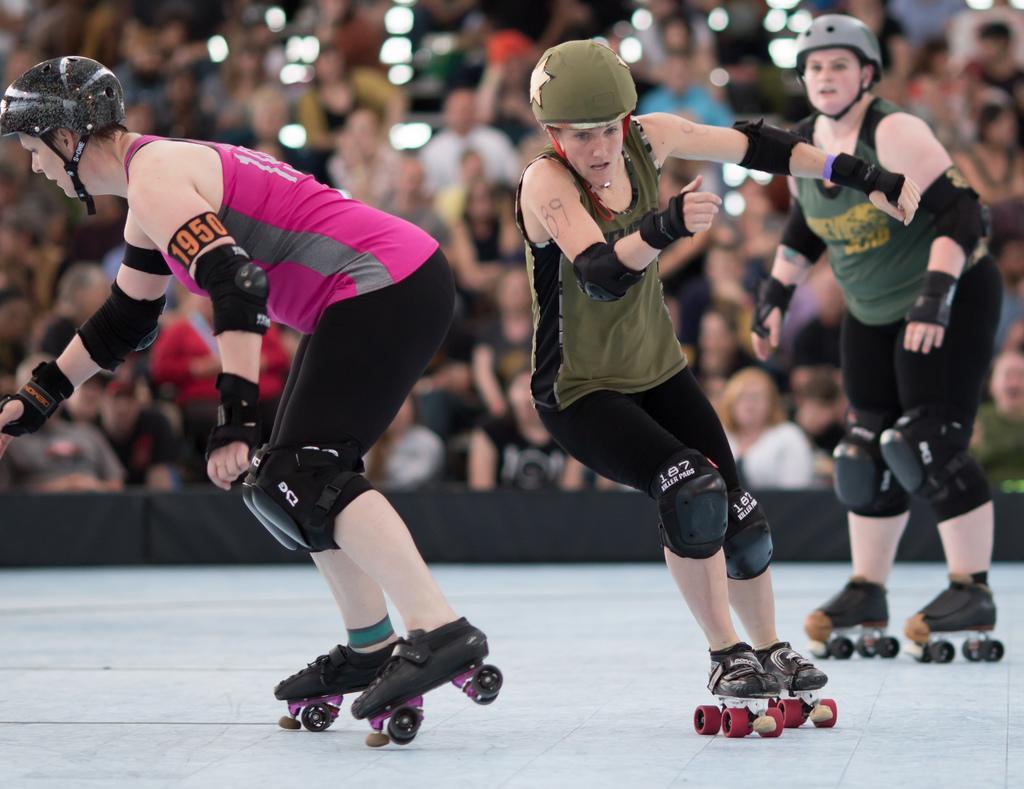How would you summarize this image in a sentence or two? In this image we can see some persons wearing skate wheels. In the background of the image there are some persons and other objects. At the bottom of the image there is the floor. 